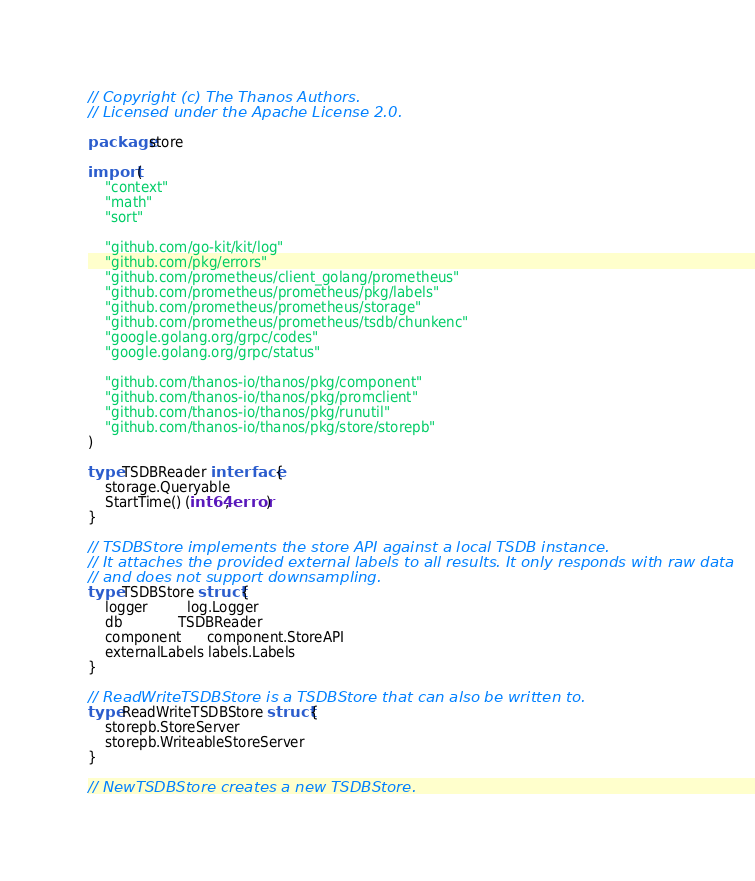Convert code to text. <code><loc_0><loc_0><loc_500><loc_500><_Go_>// Copyright (c) The Thanos Authors.
// Licensed under the Apache License 2.0.

package store

import (
	"context"
	"math"
	"sort"

	"github.com/go-kit/kit/log"
	"github.com/pkg/errors"
	"github.com/prometheus/client_golang/prometheus"
	"github.com/prometheus/prometheus/pkg/labels"
	"github.com/prometheus/prometheus/storage"
	"github.com/prometheus/prometheus/tsdb/chunkenc"
	"google.golang.org/grpc/codes"
	"google.golang.org/grpc/status"

	"github.com/thanos-io/thanos/pkg/component"
	"github.com/thanos-io/thanos/pkg/promclient"
	"github.com/thanos-io/thanos/pkg/runutil"
	"github.com/thanos-io/thanos/pkg/store/storepb"
)

type TSDBReader interface {
	storage.Queryable
	StartTime() (int64, error)
}

// TSDBStore implements the store API against a local TSDB instance.
// It attaches the provided external labels to all results. It only responds with raw data
// and does not support downsampling.
type TSDBStore struct {
	logger         log.Logger
	db             TSDBReader
	component      component.StoreAPI
	externalLabels labels.Labels
}

// ReadWriteTSDBStore is a TSDBStore that can also be written to.
type ReadWriteTSDBStore struct {
	storepb.StoreServer
	storepb.WriteableStoreServer
}

// NewTSDBStore creates a new TSDBStore.</code> 